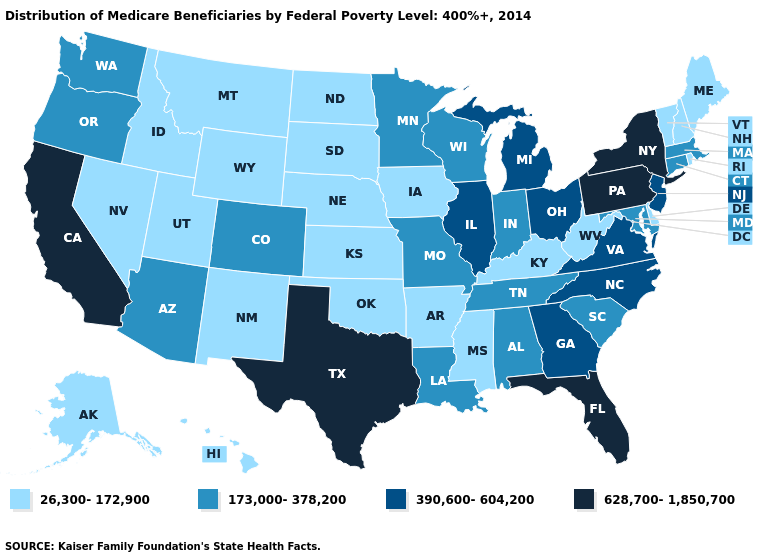Which states have the highest value in the USA?
Quick response, please. California, Florida, New York, Pennsylvania, Texas. What is the value of California?
Give a very brief answer. 628,700-1,850,700. Does Oregon have the highest value in the USA?
Write a very short answer. No. What is the value of Kansas?
Concise answer only. 26,300-172,900. What is the value of Nebraska?
Give a very brief answer. 26,300-172,900. Among the states that border Pennsylvania , which have the lowest value?
Quick response, please. Delaware, West Virginia. Among the states that border Washington , does Idaho have the lowest value?
Give a very brief answer. Yes. What is the value of Alaska?
Write a very short answer. 26,300-172,900. Name the states that have a value in the range 26,300-172,900?
Short answer required. Alaska, Arkansas, Delaware, Hawaii, Idaho, Iowa, Kansas, Kentucky, Maine, Mississippi, Montana, Nebraska, Nevada, New Hampshire, New Mexico, North Dakota, Oklahoma, Rhode Island, South Dakota, Utah, Vermont, West Virginia, Wyoming. Among the states that border New York , which have the highest value?
Answer briefly. Pennsylvania. Name the states that have a value in the range 390,600-604,200?
Write a very short answer. Georgia, Illinois, Michigan, New Jersey, North Carolina, Ohio, Virginia. Name the states that have a value in the range 390,600-604,200?
Concise answer only. Georgia, Illinois, Michigan, New Jersey, North Carolina, Ohio, Virginia. Does the first symbol in the legend represent the smallest category?
Answer briefly. Yes. Name the states that have a value in the range 628,700-1,850,700?
Write a very short answer. California, Florida, New York, Pennsylvania, Texas. 